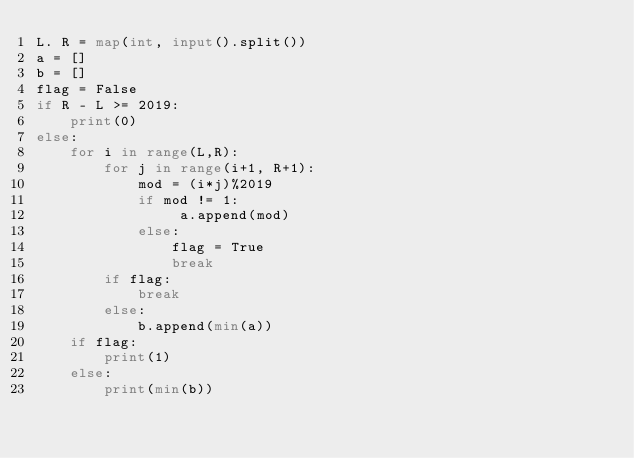<code> <loc_0><loc_0><loc_500><loc_500><_Python_>L. R = map(int, input().split())
a = []
b = []
flag = False
if R - L >= 2019:
    print(0)
else:
    for i in range(L,R):
        for j in range(i+1, R+1):
            mod = (i*j)%2019
            if mod != 1:
                 a.append(mod)
            else:
                flag = True
                break
        if flag:
            break
        else:
            b.append(min(a))
    if flag:
        print(1)
    else:
        print(min(b))</code> 